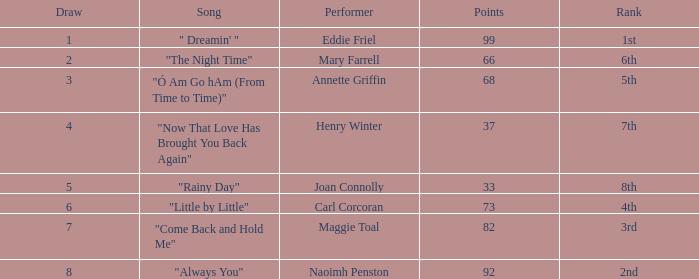What is the average number of points when the ranking is 7th and the draw is less than 4? None. 